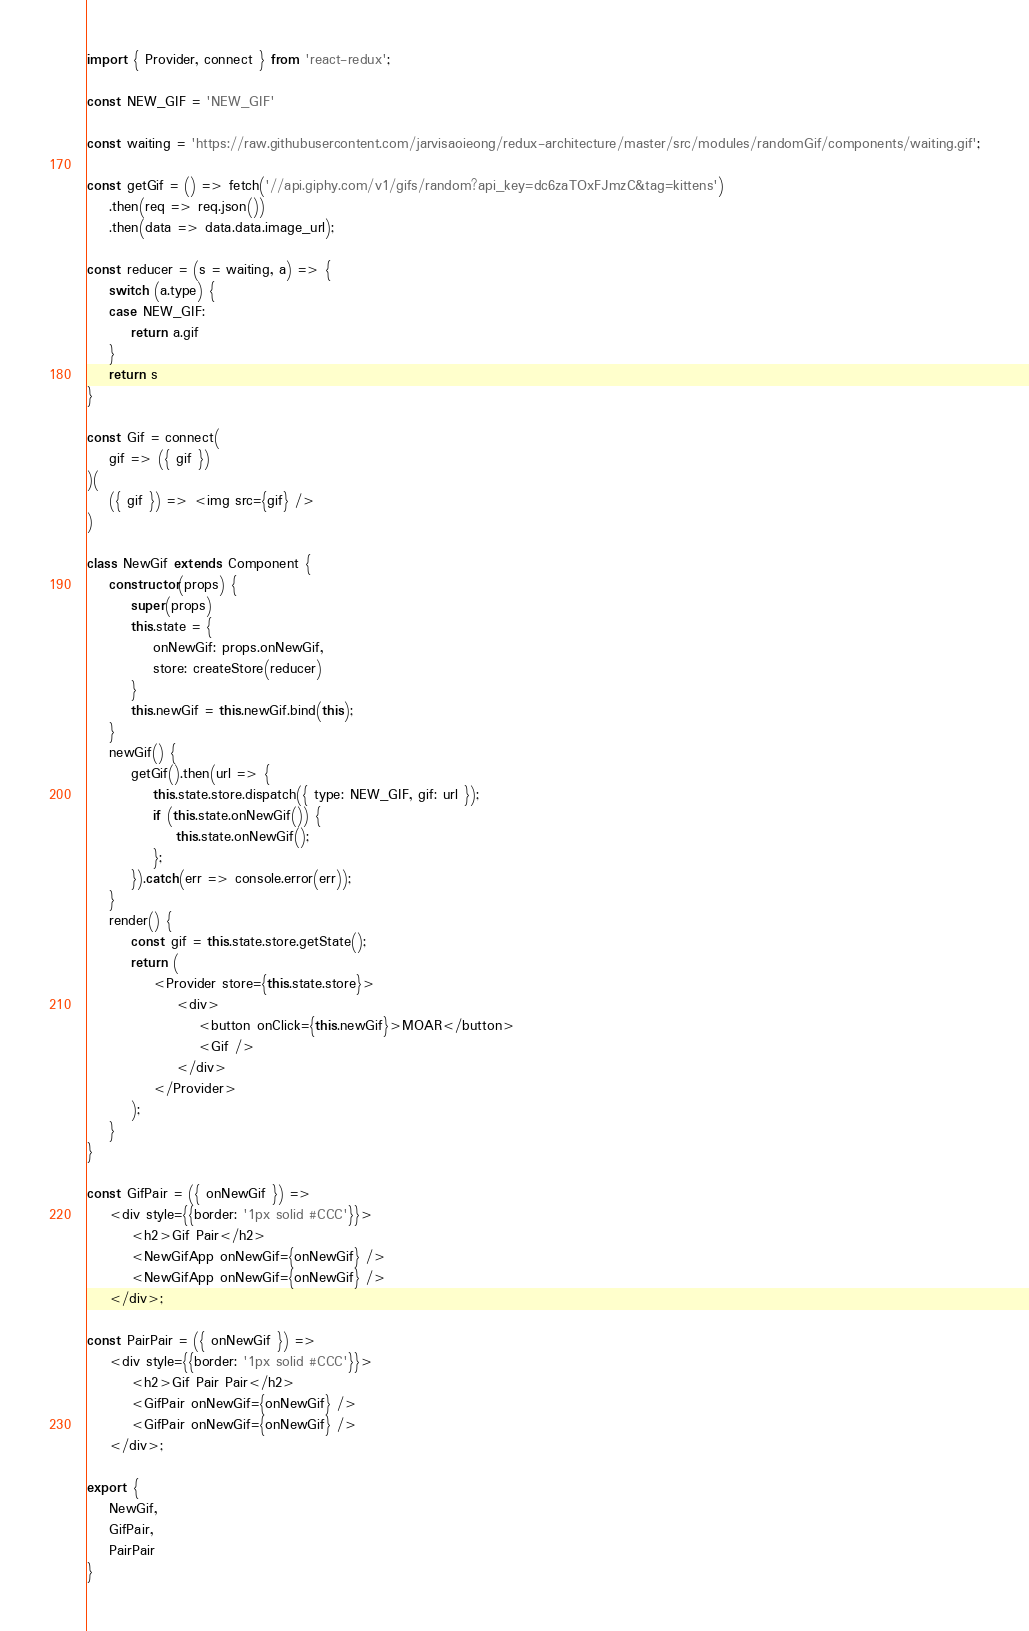<code> <loc_0><loc_0><loc_500><loc_500><_JavaScript_>import { Provider, connect } from 'react-redux';

const NEW_GIF = 'NEW_GIF'

const waiting = 'https://raw.githubusercontent.com/jarvisaoieong/redux-architecture/master/src/modules/randomGif/components/waiting.gif';

const getGif = () => fetch('//api.giphy.com/v1/gifs/random?api_key=dc6zaTOxFJmzC&tag=kittens')
    .then(req => req.json())
    .then(data => data.data.image_url);

const reducer = (s = waiting, a) => {
    switch (a.type) {
    case NEW_GIF:
        return a.gif
    }
    return s
}

const Gif = connect(
    gif => ({ gif })
)(
    ({ gif }) => <img src={gif} />
)

class NewGif extends Component {
    constructor(props) {
        super(props)
        this.state = {
            onNewGif: props.onNewGif,
            store: createStore(reducer)
        }
        this.newGif = this.newGif.bind(this);
    }
    newGif() {
        getGif().then(url => {
            this.state.store.dispatch({ type: NEW_GIF, gif: url });
            if (this.state.onNewGif()) {
                this.state.onNewGif();
            };
        }).catch(err => console.error(err));
    }
    render() {
        const gif = this.state.store.getState();
        return (
            <Provider store={this.state.store}>
                <div>
                    <button onClick={this.newGif}>MOAR</button>
                    <Gif />
                </div>
            </Provider>
        );
    }
}

const GifPair = ({ onNewGif }) =>
    <div style={{border: '1px solid #CCC'}}>
        <h2>Gif Pair</h2>
        <NewGifApp onNewGif={onNewGif} />
        <NewGifApp onNewGif={onNewGif} />
    </div>;

const PairPair = ({ onNewGif }) =>
    <div style={{border: '1px solid #CCC'}}>
        <h2>Gif Pair Pair</h2>
        <GifPair onNewGif={onNewGif} />
        <GifPair onNewGif={onNewGif} />
    </div>;

export {
    NewGif,
    GifPair,
    PairPair
}
</code> 